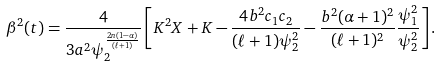Convert formula to latex. <formula><loc_0><loc_0><loc_500><loc_500>\beta ^ { 2 } ( t ) = \frac { 4 } { 3 a ^ { 2 } \psi _ { 2 } ^ { \frac { 2 n ( 1 - \alpha ) } { ( \ell + 1 ) } } } \left [ K ^ { 2 } X + K - \frac { 4 b ^ { 2 } c _ { 1 } c _ { 2 } } { ( \ell + 1 ) \psi _ { 2 } ^ { 2 } } - \frac { b ^ { 2 } ( \alpha + 1 ) ^ { 2 } } { ( \ell + 1 ) ^ { 2 } } \frac { \psi _ { 1 } ^ { 2 } } { \psi _ { 2 } ^ { 2 } } \right ] .</formula> 